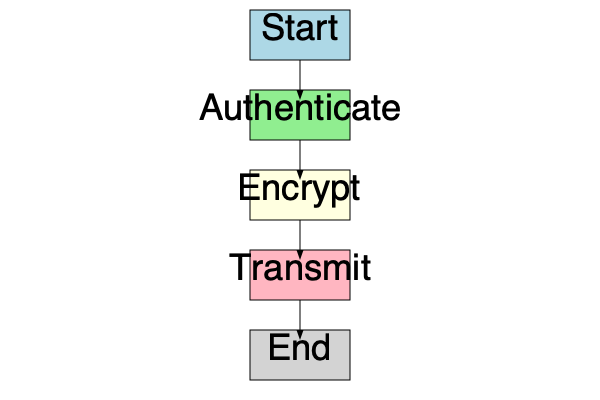In the flowchart of a secure communication protocol for industrial automation systems, what is the correct sequence of steps after the "Start" phase? The flowchart illustrates the steps of a secure communication protocol for industrial automation systems. Let's analyze the sequence:

1. The process begins with the "Start" phase, which initializes the communication.

2. The next step is "Authenticate". This is crucial in secure protocols to verify the identity of the communicating parties, preventing unauthorized access to the system.

3. Following authentication, the protocol moves to the "Encrypt" phase. Encryption is essential to protect the confidentiality of the data being transmitted, ensuring that even if intercepted, the information remains unreadable to unauthorized entities.

4. After encryption, the protocol proceeds to the "Transmit" phase. This is where the authenticated and encrypted data is actually sent over the network.

5. Finally, the process reaches the "End" phase, indicating the completion of the secure communication sequence.

This sequence ensures that data is first authenticated to verify the sender's identity, then encrypted to maintain confidentiality, and only then transmitted, providing a robust security model for industrial automation systems.
Answer: Authenticate, Encrypt, Transmit 